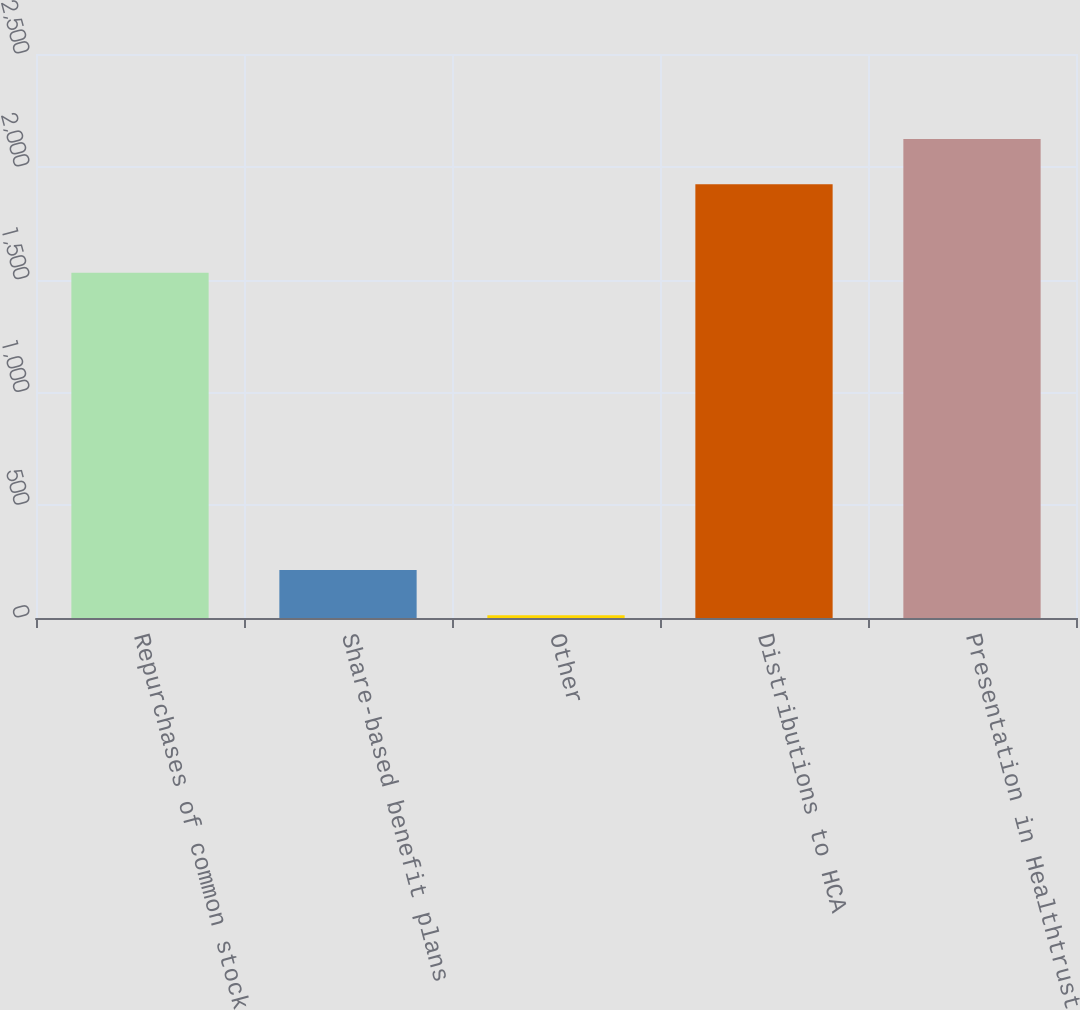<chart> <loc_0><loc_0><loc_500><loc_500><bar_chart><fcel>Repurchases of common stock<fcel>Share-based benefit plans<fcel>Other<fcel>Distributions to HCA<fcel>Presentation in Healthtrust<nl><fcel>1530<fcel>212.5<fcel>12<fcel>1923<fcel>2123.5<nl></chart> 